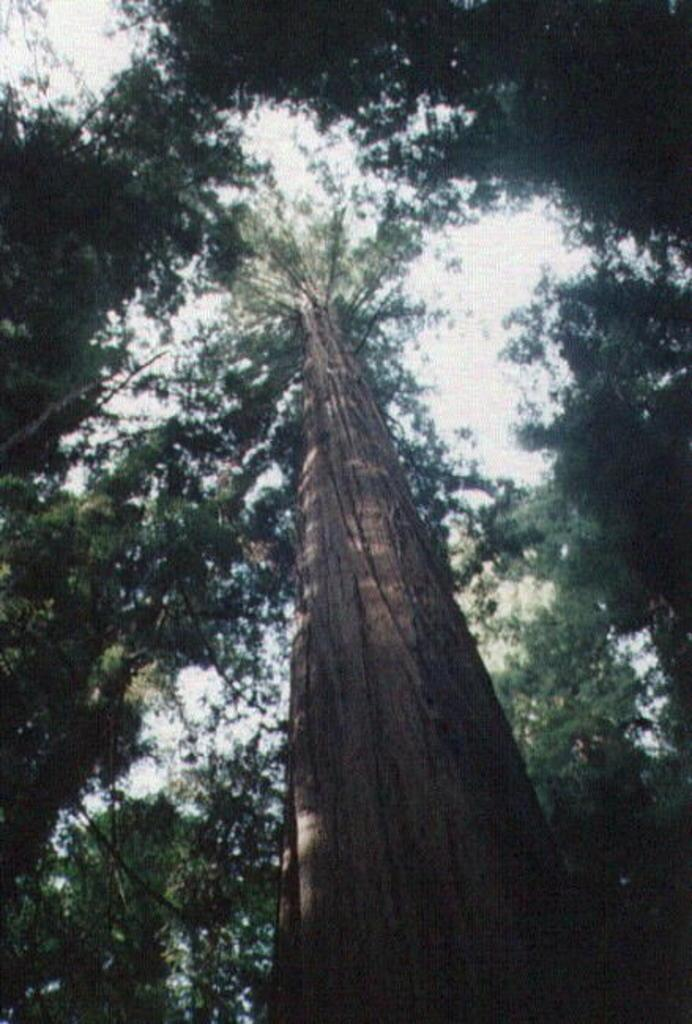How is the image taken in relation to the subject? The image is taken at a low angle. What can be seen in the background of the image? There are trees and the sky visible in the background of the image. What type of brain surgery is being performed in the image? There is no brain surgery or doctor present in the image; it features a low angle and trees in the background. 